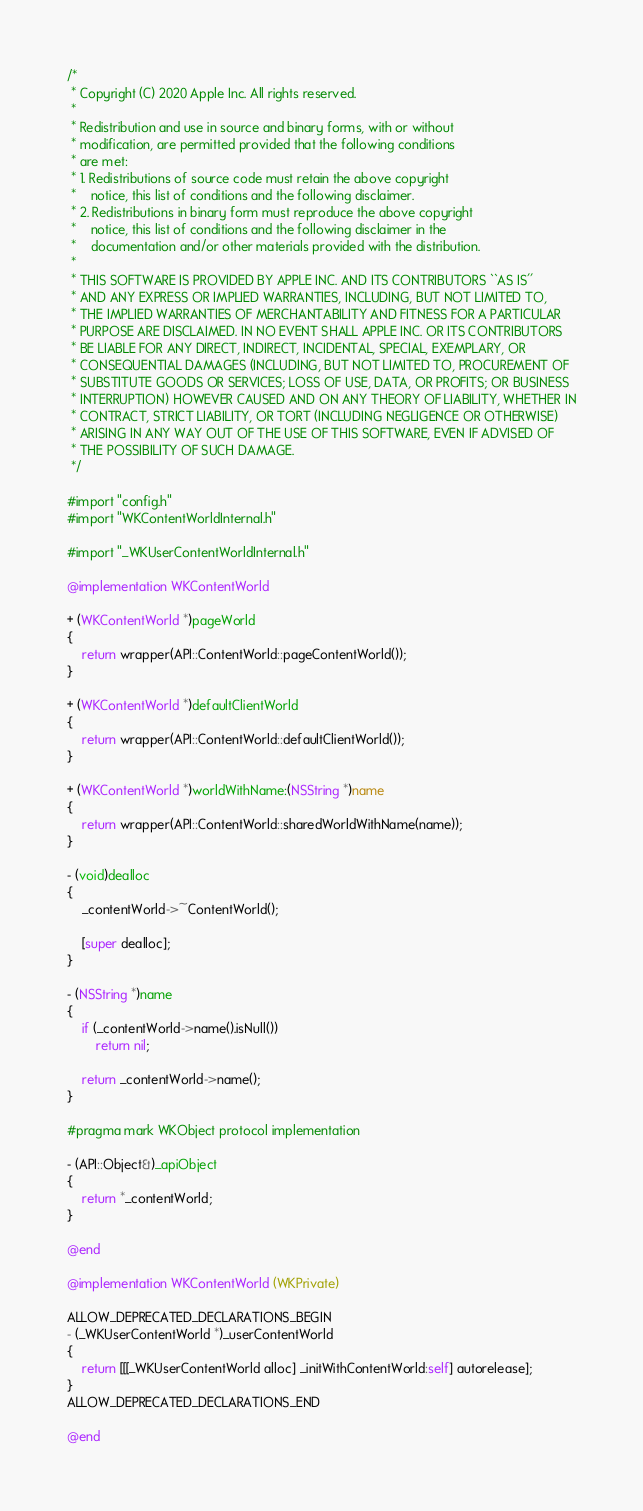Convert code to text. <code><loc_0><loc_0><loc_500><loc_500><_ObjectiveC_>/*
 * Copyright (C) 2020 Apple Inc. All rights reserved.
 *
 * Redistribution and use in source and binary forms, with or without
 * modification, are permitted provided that the following conditions
 * are met:
 * 1. Redistributions of source code must retain the above copyright
 *    notice, this list of conditions and the following disclaimer.
 * 2. Redistributions in binary form must reproduce the above copyright
 *    notice, this list of conditions and the following disclaimer in the
 *    documentation and/or other materials provided with the distribution.
 *
 * THIS SOFTWARE IS PROVIDED BY APPLE INC. AND ITS CONTRIBUTORS ``AS IS''
 * AND ANY EXPRESS OR IMPLIED WARRANTIES, INCLUDING, BUT NOT LIMITED TO,
 * THE IMPLIED WARRANTIES OF MERCHANTABILITY AND FITNESS FOR A PARTICULAR
 * PURPOSE ARE DISCLAIMED. IN NO EVENT SHALL APPLE INC. OR ITS CONTRIBUTORS
 * BE LIABLE FOR ANY DIRECT, INDIRECT, INCIDENTAL, SPECIAL, EXEMPLARY, OR
 * CONSEQUENTIAL DAMAGES (INCLUDING, BUT NOT LIMITED TO, PROCUREMENT OF
 * SUBSTITUTE GOODS OR SERVICES; LOSS OF USE, DATA, OR PROFITS; OR BUSINESS
 * INTERRUPTION) HOWEVER CAUSED AND ON ANY THEORY OF LIABILITY, WHETHER IN
 * CONTRACT, STRICT LIABILITY, OR TORT (INCLUDING NEGLIGENCE OR OTHERWISE)
 * ARISING IN ANY WAY OUT OF THE USE OF THIS SOFTWARE, EVEN IF ADVISED OF
 * THE POSSIBILITY OF SUCH DAMAGE.
 */

#import "config.h"
#import "WKContentWorldInternal.h"

#import "_WKUserContentWorldInternal.h"

@implementation WKContentWorld

+ (WKContentWorld *)pageWorld
{
    return wrapper(API::ContentWorld::pageContentWorld());
}

+ (WKContentWorld *)defaultClientWorld
{
    return wrapper(API::ContentWorld::defaultClientWorld());
}

+ (WKContentWorld *)worldWithName:(NSString *)name
{
    return wrapper(API::ContentWorld::sharedWorldWithName(name));
}

- (void)dealloc
{
    _contentWorld->~ContentWorld();

    [super dealloc];
}

- (NSString *)name
{
    if (_contentWorld->name().isNull())
        return nil;

    return _contentWorld->name();
}

#pragma mark WKObject protocol implementation

- (API::Object&)_apiObject
{
    return *_contentWorld;
}

@end

@implementation WKContentWorld (WKPrivate)

ALLOW_DEPRECATED_DECLARATIONS_BEGIN
- (_WKUserContentWorld *)_userContentWorld
{
    return [[[_WKUserContentWorld alloc] _initWithContentWorld:self] autorelease];
}
ALLOW_DEPRECATED_DECLARATIONS_END

@end
</code> 